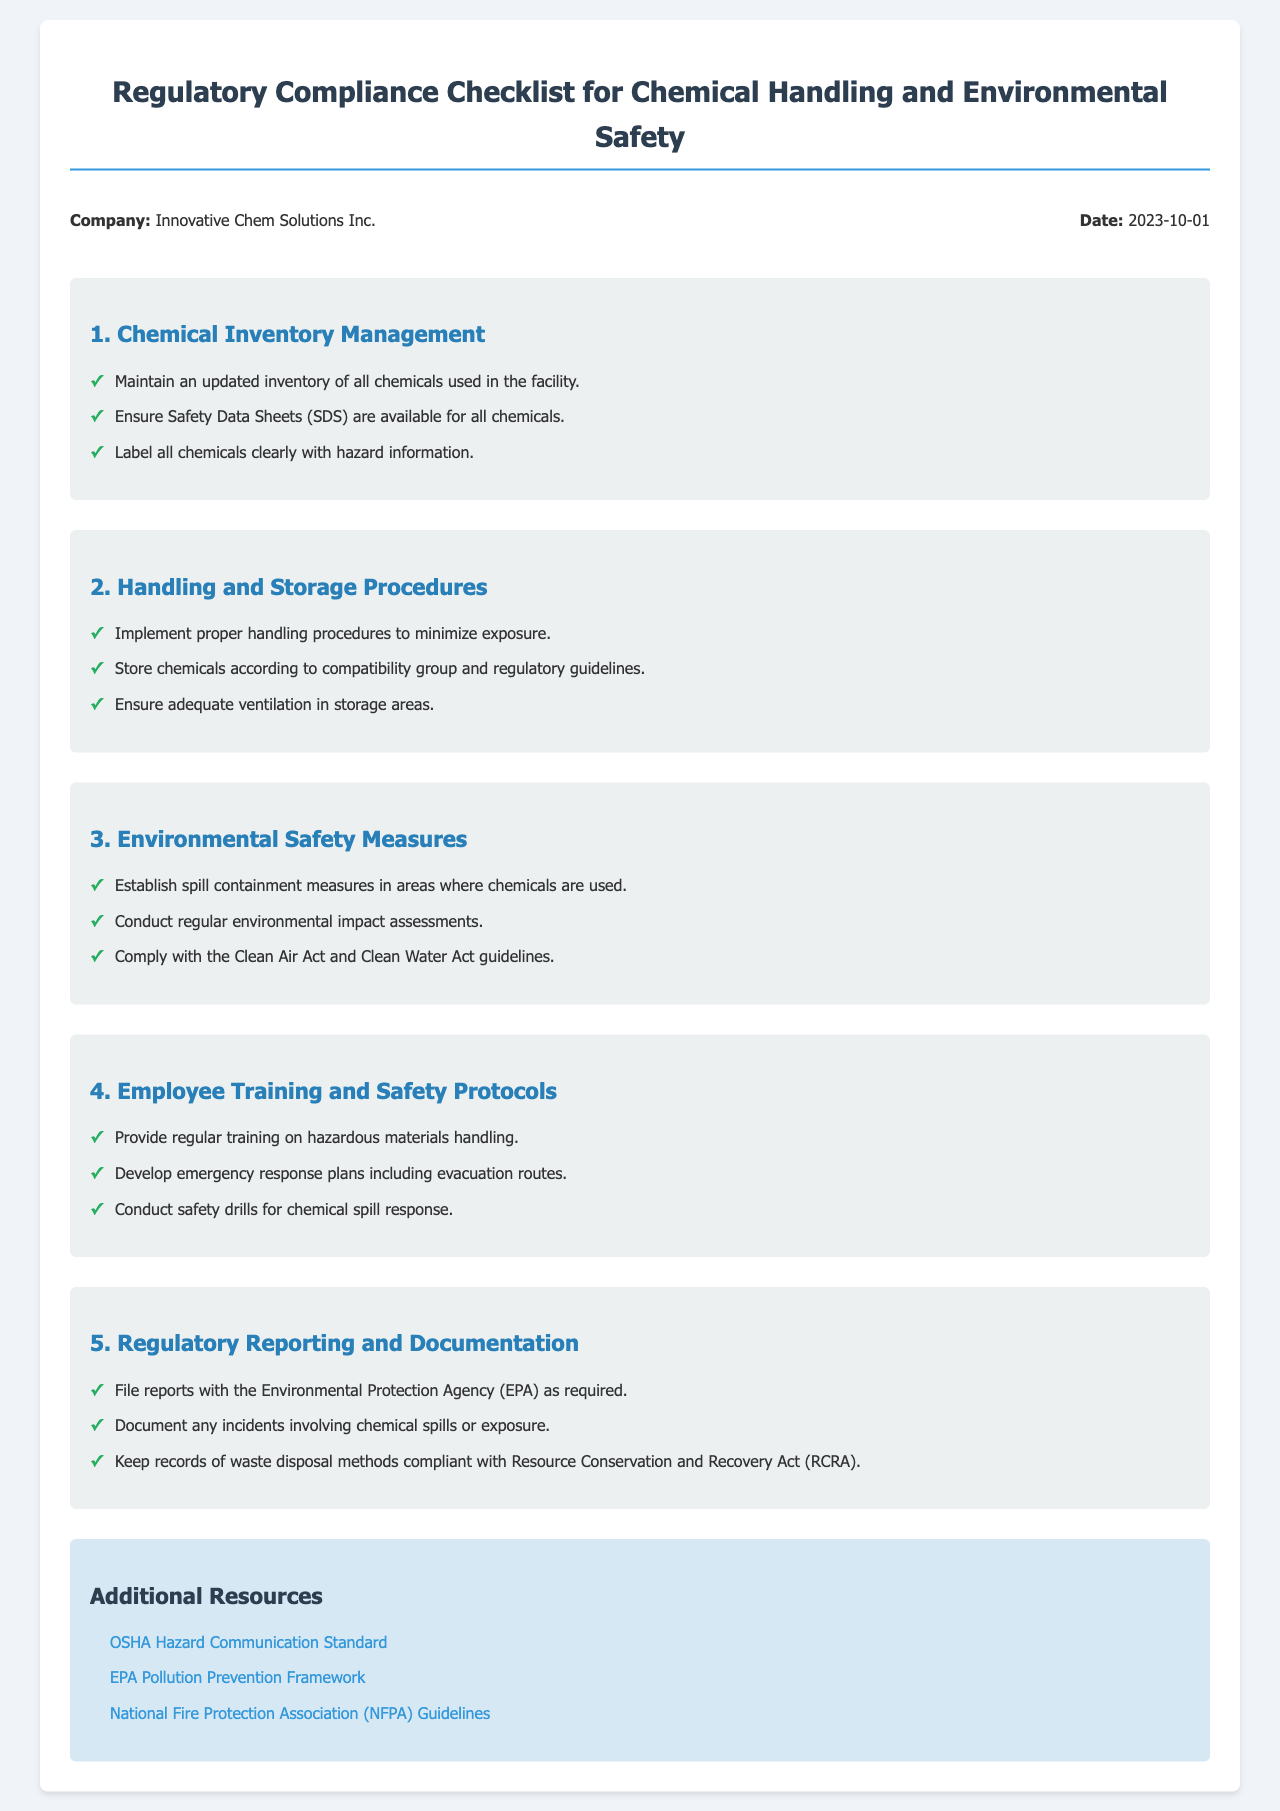What is the name of the company? The company name is stated at the header of the document.
Answer: Innovative Chem Solutions Inc What is the date of the document? The date is also mentioned in the header information section.
Answer: 2023-10-01 Which act is mentioned regarding air compliance? The document lists specific guidelines that must be followed for environmental safety.
Answer: Clean Air Act How many sections are there in the checklist? The number of main sections can be counted from the document.
Answer: 5 What are the guidelines for employee training? The document outlines specific training requirements in one of its sections.
Answer: Regular training on hazardous materials handling What is included in the environmental safety measures? These measures are outlined in a specific section of the checklist.
Answer: Spill containment measures What should be documented concerning chemical spills? The document specifies the type of incident that must be recorded.
Answer: Any incidents involving chemical spills or exposure Which organization requires reports to be filed? The document refers to a specific agency that mandates reporting.
Answer: Environmental Protection Agency (EPA) What type of training should be provided regularly? The document explains the necessary training for employees involved in chemical handling.
Answer: Training on hazardous materials handling 